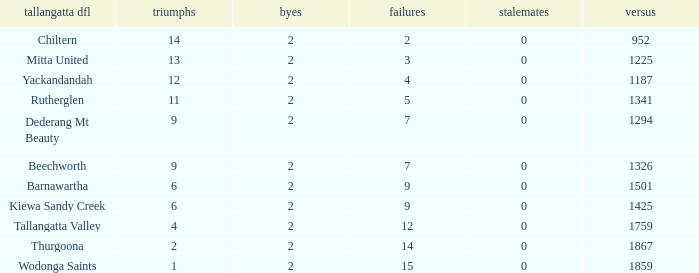What are the losses when there are 9 wins and more than 1326 against? None. 